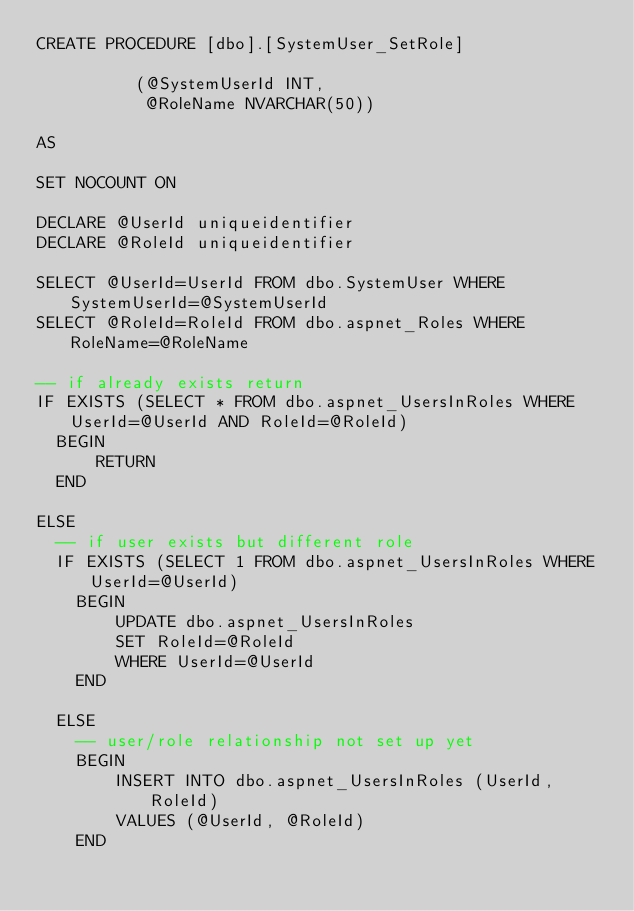<code> <loc_0><loc_0><loc_500><loc_500><_SQL_>CREATE PROCEDURE [dbo].[SystemUser_SetRole]

					(@SystemUserId INT,
					 @RoleName NVARCHAR(50))

AS

SET NOCOUNT ON

DECLARE @UserId uniqueidentifier
DECLARE @RoleId uniqueidentifier

SELECT @UserId=UserId FROM dbo.SystemUser WHERE SystemUserId=@SystemUserId
SELECT @RoleId=RoleId FROM dbo.aspnet_Roles WHERE RoleName=@RoleName

-- if already exists return
IF EXISTS (SELECT * FROM dbo.aspnet_UsersInRoles WHERE UserId=@UserId AND RoleId=@RoleId)
	BEGIN
			RETURN	
	END

ELSE
	-- if user exists but different role
	IF EXISTS (SELECT 1 FROM dbo.aspnet_UsersInRoles WHERE UserId=@UserId)
		BEGIN
				UPDATE dbo.aspnet_UsersInRoles
				SET RoleId=@RoleId
				WHERE UserId=@UserId
		END
		
	ELSE
		-- user/role relationship not set up yet
		BEGIN
				INSERT INTO dbo.aspnet_UsersInRoles (UserId, RoleId)
				VALUES (@UserId, @RoleId)
		END		



</code> 